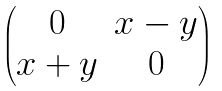<formula> <loc_0><loc_0><loc_500><loc_500>\begin{pmatrix} 0 & x - y \\ x + y & 0 \end{pmatrix}</formula> 